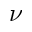<formula> <loc_0><loc_0><loc_500><loc_500>\nu</formula> 